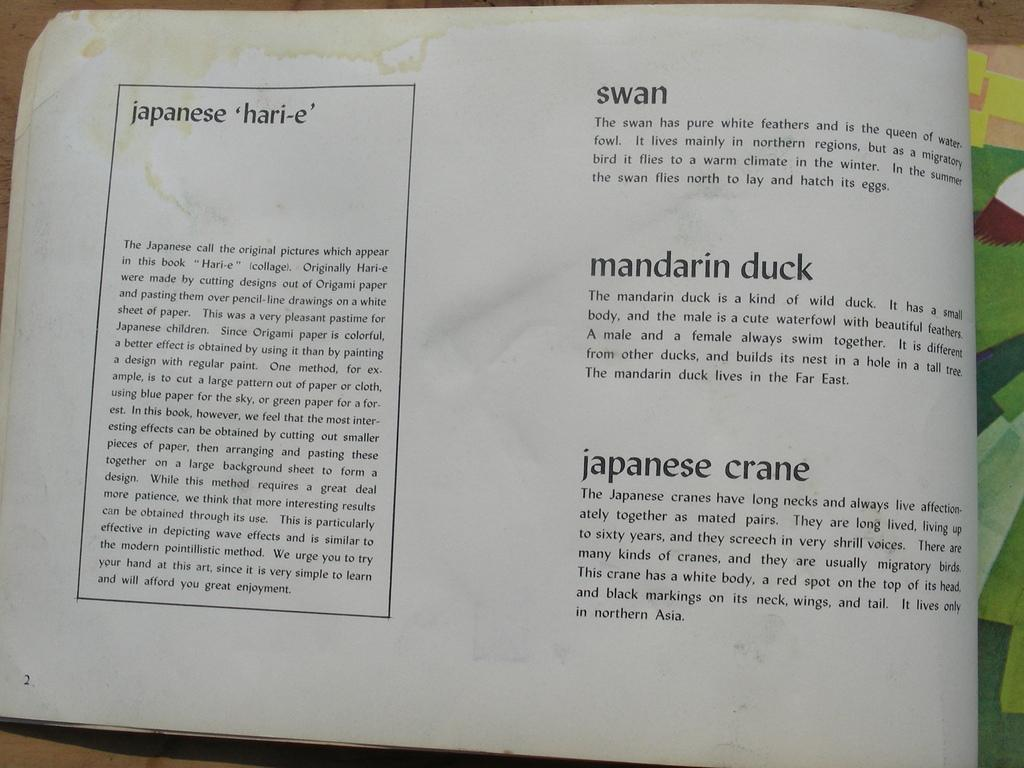<image>
Create a compact narrative representing the image presented. Open book with the word swan near the top. 